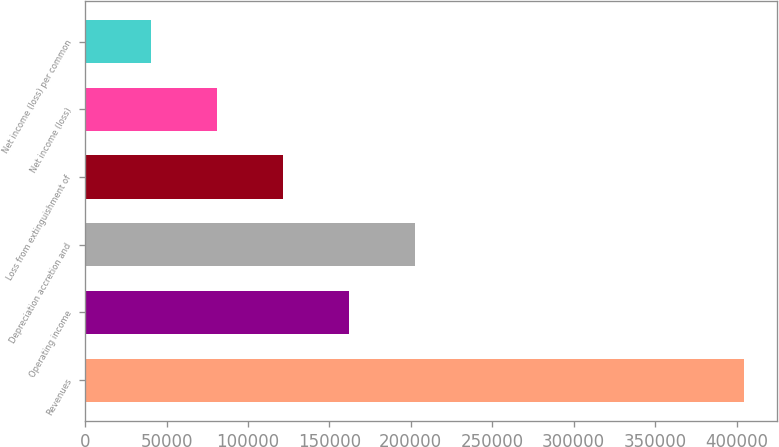Convert chart to OTSL. <chart><loc_0><loc_0><loc_500><loc_500><bar_chart><fcel>Revenues<fcel>Operating income<fcel>Depreciation accretion and<fcel>Loss from extinguishment of<fcel>Net income (loss)<fcel>Net income (loss) per common<nl><fcel>404734<fcel>161895<fcel>202368<fcel>121422<fcel>80949.1<fcel>40476<nl></chart> 